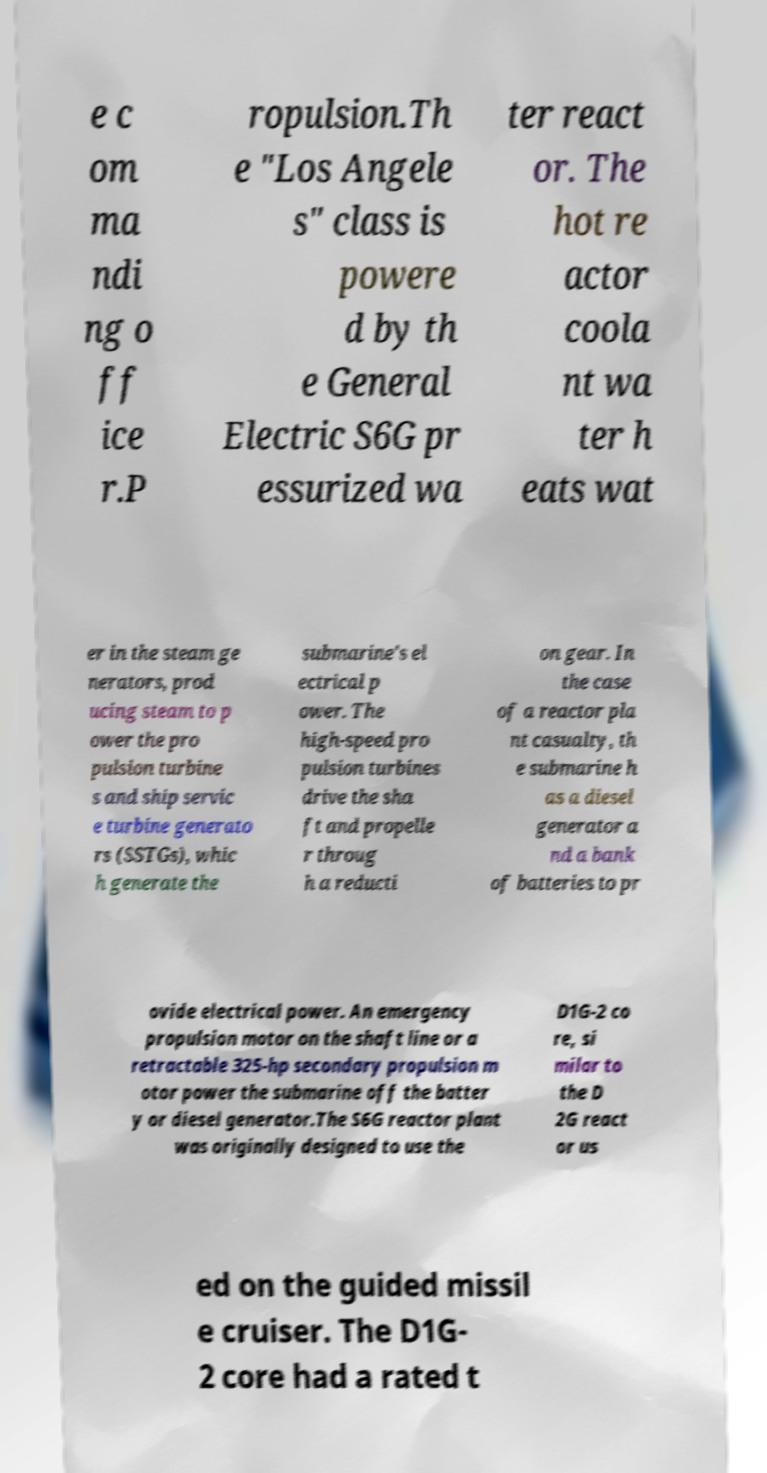Could you extract and type out the text from this image? e c om ma ndi ng o ff ice r.P ropulsion.Th e "Los Angele s" class is powere d by th e General Electric S6G pr essurized wa ter react or. The hot re actor coola nt wa ter h eats wat er in the steam ge nerators, prod ucing steam to p ower the pro pulsion turbine s and ship servic e turbine generato rs (SSTGs), whic h generate the submarine's el ectrical p ower. The high-speed pro pulsion turbines drive the sha ft and propelle r throug h a reducti on gear. In the case of a reactor pla nt casualty, th e submarine h as a diesel generator a nd a bank of batteries to pr ovide electrical power. An emergency propulsion motor on the shaft line or a retractable 325-hp secondary propulsion m otor power the submarine off the batter y or diesel generator.The S6G reactor plant was originally designed to use the D1G-2 co re, si milar to the D 2G react or us ed on the guided missil e cruiser. The D1G- 2 core had a rated t 